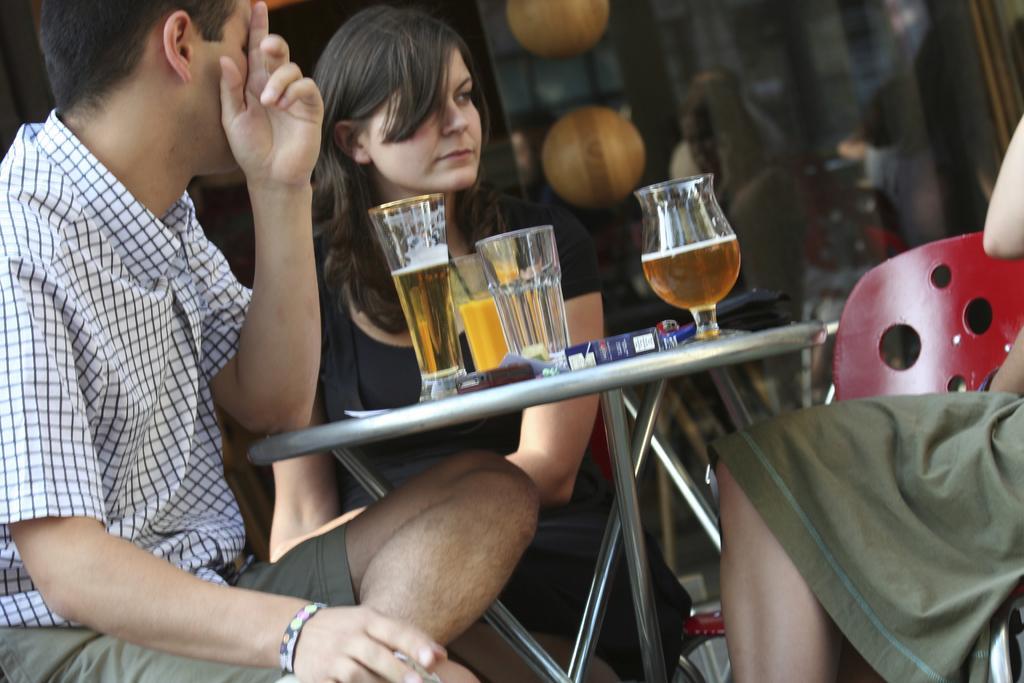How would you summarize this image in a sentence or two? In this picture, we see three people are sitting on the chairs. In front of them, we see a table on which glasses containing liquids, a blue color box, a black wallet and some other objects are placed. In the background, we see the lanterns and the glass windows from which we can see the people who are sitting on the chairs. 